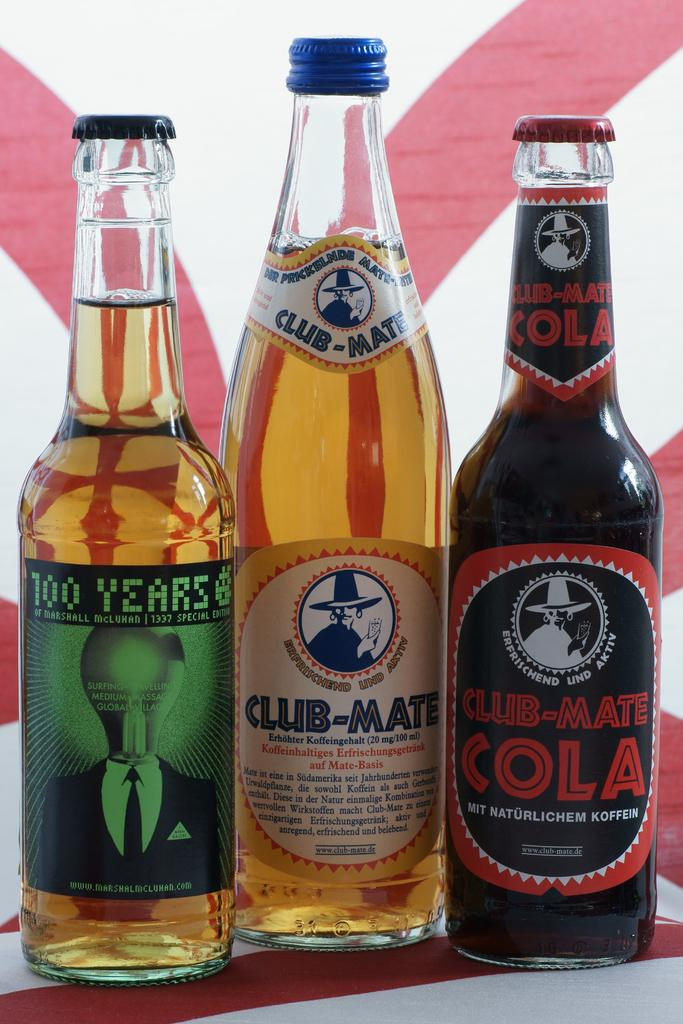<image>
Write a terse but informative summary of the picture. Three bottles placed side by side including Club-Mate Cola. 